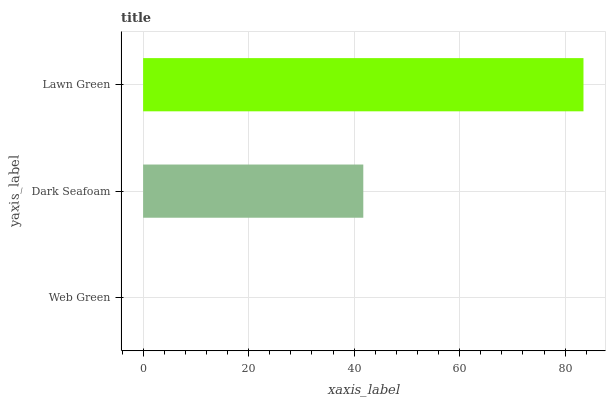Is Web Green the minimum?
Answer yes or no. Yes. Is Lawn Green the maximum?
Answer yes or no. Yes. Is Dark Seafoam the minimum?
Answer yes or no. No. Is Dark Seafoam the maximum?
Answer yes or no. No. Is Dark Seafoam greater than Web Green?
Answer yes or no. Yes. Is Web Green less than Dark Seafoam?
Answer yes or no. Yes. Is Web Green greater than Dark Seafoam?
Answer yes or no. No. Is Dark Seafoam less than Web Green?
Answer yes or no. No. Is Dark Seafoam the high median?
Answer yes or no. Yes. Is Dark Seafoam the low median?
Answer yes or no. Yes. Is Web Green the high median?
Answer yes or no. No. Is Web Green the low median?
Answer yes or no. No. 